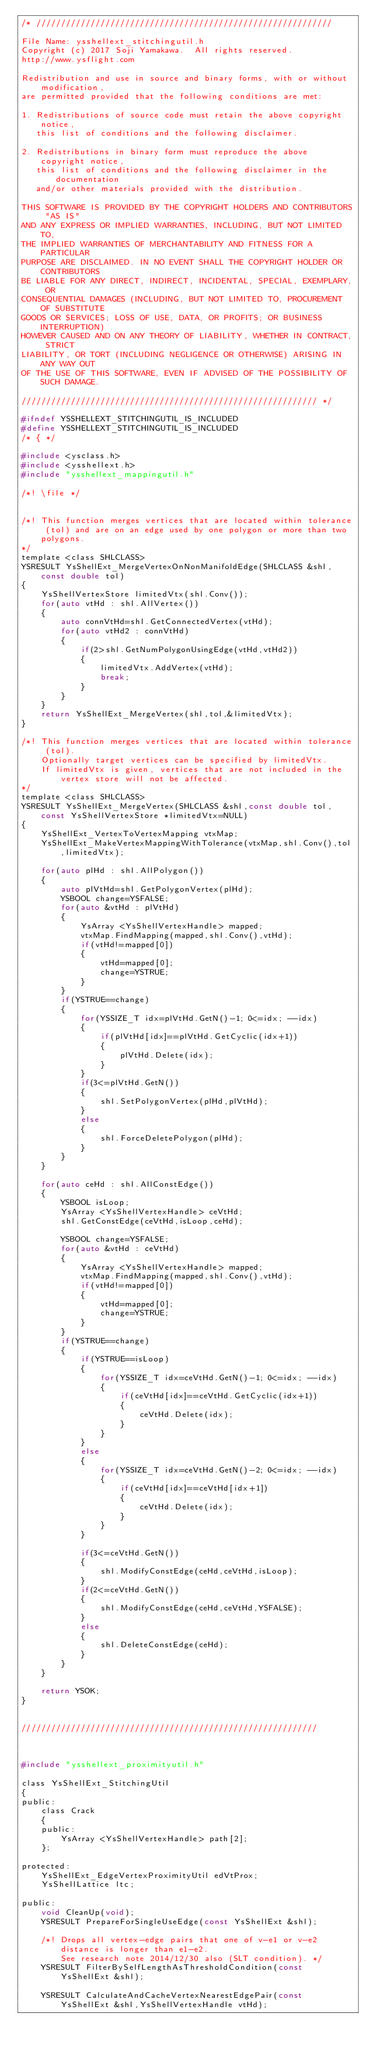Convert code to text. <code><loc_0><loc_0><loc_500><loc_500><_C_>/* ////////////////////////////////////////////////////////////

File Name: ysshellext_stitchingutil.h
Copyright (c) 2017 Soji Yamakawa.  All rights reserved.
http://www.ysflight.com

Redistribution and use in source and binary forms, with or without modification, 
are permitted provided that the following conditions are met:

1. Redistributions of source code must retain the above copyright notice, 
   this list of conditions and the following disclaimer.

2. Redistributions in binary form must reproduce the above copyright notice, 
   this list of conditions and the following disclaimer in the documentation 
   and/or other materials provided with the distribution.

THIS SOFTWARE IS PROVIDED BY THE COPYRIGHT HOLDERS AND CONTRIBUTORS "AS IS" 
AND ANY EXPRESS OR IMPLIED WARRANTIES, INCLUDING, BUT NOT LIMITED TO, 
THE IMPLIED WARRANTIES OF MERCHANTABILITY AND FITNESS FOR A PARTICULAR 
PURPOSE ARE DISCLAIMED. IN NO EVENT SHALL THE COPYRIGHT HOLDER OR CONTRIBUTORS 
BE LIABLE FOR ANY DIRECT, INDIRECT, INCIDENTAL, SPECIAL, EXEMPLARY, OR 
CONSEQUENTIAL DAMAGES (INCLUDING, BUT NOT LIMITED TO, PROCUREMENT OF SUBSTITUTE 
GOODS OR SERVICES; LOSS OF USE, DATA, OR PROFITS; OR BUSINESS INTERRUPTION) 
HOWEVER CAUSED AND ON ANY THEORY OF LIABILITY, WHETHER IN CONTRACT, STRICT 
LIABILITY, OR TORT (INCLUDING NEGLIGENCE OR OTHERWISE) ARISING IN ANY WAY OUT 
OF THE USE OF THIS SOFTWARE, EVEN IF ADVISED OF THE POSSIBILITY OF SUCH DAMAGE.

//////////////////////////////////////////////////////////// */

#ifndef YSSHELLEXT_STITCHINGUTIL_IS_INCLUDED
#define YSSHELLEXT_STITCHINGUTIL_IS_INCLUDED
/* { */

#include <ysclass.h>
#include <ysshellext.h>
#include "ysshellext_mappingutil.h"

/*! \file */


/*! This function merges vertices that are located within tolerance (tol) and are on an edge used by one polygon or more than two polygons.
*/
template <class SHLCLASS>
YSRESULT YsShellExt_MergeVertexOnNonManifoldEdge(SHLCLASS &shl,const double tol)
{
	YsShellVertexStore limitedVtx(shl.Conv());
	for(auto vtHd : shl.AllVertex())
	{
		auto connVtHd=shl.GetConnectedVertex(vtHd);
		for(auto vtHd2 : connVtHd)
		{
			if(2>shl.GetNumPolygonUsingEdge(vtHd,vtHd2))
			{
				limitedVtx.AddVertex(vtHd);
				break;
			}
		}
	}
	return YsShellExt_MergeVertex(shl,tol,&limitedVtx);
}

/*! This function merges vertices that are located within tolerance (tol).
    Optionally target vertices can be specified by limitedVtx.  
    If limitedVtx is given, vertices that are not included in the vertex store will not be affected.
*/
template <class SHLCLASS>
YSRESULT YsShellExt_MergeVertex(SHLCLASS &shl,const double tol,const YsShellVertexStore *limitedVtx=NULL)
{
	YsShellExt_VertexToVertexMapping vtxMap;
	YsShellExt_MakeVertexMappingWithTolerance(vtxMap,shl.Conv(),tol,limitedVtx);

	for(auto plHd : shl.AllPolygon())
	{
		auto plVtHd=shl.GetPolygonVertex(plHd);
		YSBOOL change=YSFALSE;
		for(auto &vtHd : plVtHd)
		{
			YsArray <YsShellVertexHandle> mapped;
			vtxMap.FindMapping(mapped,shl.Conv(),vtHd);
			if(vtHd!=mapped[0])
			{
				vtHd=mapped[0];
				change=YSTRUE;
			}
		}
		if(YSTRUE==change)
		{
			for(YSSIZE_T idx=plVtHd.GetN()-1; 0<=idx; --idx)
			{
				if(plVtHd[idx]==plVtHd.GetCyclic(idx+1))
				{
					plVtHd.Delete(idx);
				}
			}
			if(3<=plVtHd.GetN())
			{
				shl.SetPolygonVertex(plHd,plVtHd);
			}
			else
			{
				shl.ForceDeletePolygon(plHd);
			}
		}
	}

	for(auto ceHd : shl.AllConstEdge())
	{
		YSBOOL isLoop;
		YsArray <YsShellVertexHandle> ceVtHd;
		shl.GetConstEdge(ceVtHd,isLoop,ceHd);

		YSBOOL change=YSFALSE;
		for(auto &vtHd : ceVtHd)
		{
			YsArray <YsShellVertexHandle> mapped;
			vtxMap.FindMapping(mapped,shl.Conv(),vtHd);
			if(vtHd!=mapped[0])
			{
				vtHd=mapped[0];
				change=YSTRUE;
			}
		}
		if(YSTRUE==change)
		{
			if(YSTRUE==isLoop)
			{
				for(YSSIZE_T idx=ceVtHd.GetN()-1; 0<=idx; --idx)
				{
					if(ceVtHd[idx]==ceVtHd.GetCyclic(idx+1))
					{
						ceVtHd.Delete(idx);
					}
				}
			}
			else
			{
				for(YSSIZE_T idx=ceVtHd.GetN()-2; 0<=idx; --idx)
				{
					if(ceVtHd[idx]==ceVtHd[idx+1])
					{
						ceVtHd.Delete(idx);
					}
				}
			}

			if(3<=ceVtHd.GetN())
			{
				shl.ModifyConstEdge(ceHd,ceVtHd,isLoop);
			}
			if(2<=ceVtHd.GetN())
			{
				shl.ModifyConstEdge(ceHd,ceVtHd,YSFALSE);
			}
			else
			{
				shl.DeleteConstEdge(ceHd);
			}
		}
	}

	return YSOK;
}


////////////////////////////////////////////////////////////



#include "ysshellext_proximityutil.h"

class YsShellExt_StitchingUtil
{
public:
	class Crack
	{
	public:
		YsArray <YsShellVertexHandle> path[2];
	};

protected:
	YsShellExt_EdgeVertexProximityUtil edVtProx;
	YsShellLattice ltc;

public:
	void CleanUp(void);
	YSRESULT PrepareForSingleUseEdge(const YsShellExt &shl);

	/*! Drops all vertex-edge pairs that one of v-e1 or v-e2 distance is longer than e1-e2. 
	    See research note 2014/12/30 also (SLT condition). */
	YSRESULT FilterBySelfLengthAsThresholdCondition(const YsShellExt &shl);

	YSRESULT CalculateAndCacheVertexNearestEdgePair(const YsShellExt &shl,YsShellVertexHandle vtHd);
</code> 